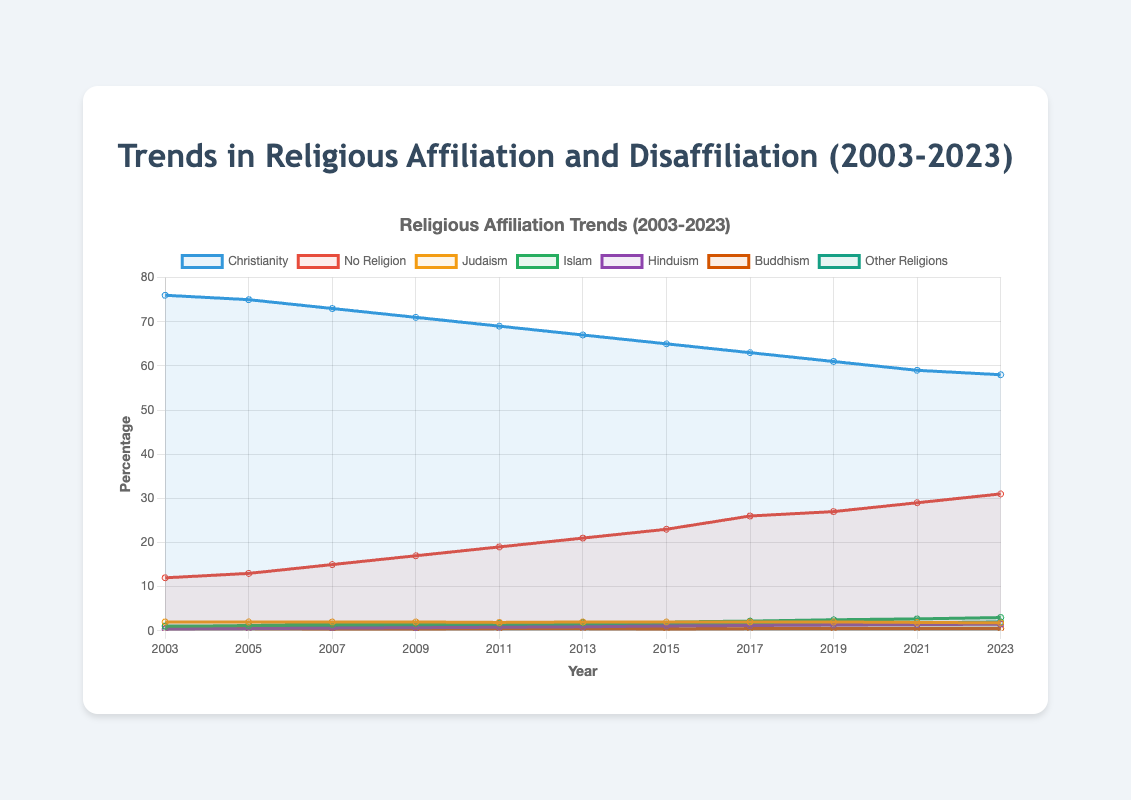What is the general trend of Christianity from 2003 to 2023? The line representing Christianity shows a decreasing trend from 76% in 2003 to 58% in 2023. Observing the overall direction of the line, it is evident that the percentage has consistently dropped over the 20-year period.
Answer: Decreasing Which religious affiliation had the highest increase in percentage over the 20 years, and by how much did it increase? To find the highest increase, we compare the percentages for each religion from 2003 to 2023. The "No Religion" category increased from 12% to 31%, a change of 19 percentage points. No other category saw a greater increase.
Answer: No Religion, 19 percentage points Between 2015 and 2023, which religion saw the highest growth rate? Calculate the growth rates for each religion between 2015 and 2023 by dividing the percentage increase by the number of years. "Islam" increased from 2% to 3%, a 1% increase over 8 years, equating to a growth rate of 0.125 percent per year, the highest among the groups.
Answer: Islam How does the percentage of people identifying as "No Religion" in 2023 compare to those identifying as "Christianity"? In 2023, "No Religion" has 31% and "Christianity" has 58%. We see that Christianity's percentage is higher than "No Religion" by comparing their values directly.
Answer: Christianity is higher by 27% Which group remained relatively stable over the period from 2003 to 2023, and what was the change in percentage? Looking at the lines, "Buddhism" shows minimal fluctuation, remaining around 0.5% throughout the years with only minor variations. The change in percentage is negligible.
Answer: Buddhism, around 0% In which year did "No Religion" overtake "Christianity" as the second-highest percentage, if at all? By examining the crossing points of the lines, we observe that "No Religion" never overtakes "Christianity" but steadily increases over the years while Christianity decreases. "Christianity" consistently maintains a higher percentage.
Answer: Never overtakes Among the minority religions listed (Judaism, Islam, Hinduism, Buddhism, Other Religions), which one showed the most steady increase from 2003 to 2023 and how can you tell? "Islam" shows a steady increase with no significant dips or rises, progressing consistently from 1% in 2003 to 3% in 2023. The smooth upward line indicates this steady increase.
Answer: Islam What is the combined percentage of Islam and Hinduism in 2023, and what does it suggest about their growth? The percentage for Islam is 3%, and for Hinduism, it is 1.5% in 2023. Summing them gives 3% + 1.5% = 4.5%. This combined value suggests both religions have been slowly but steadily growing over the years.
Answer: 4.5% Compare the percentages of people identifying with "Other Religions" in 2003 and 2023. What is the percentage increase? "Other Religions" increased from 1.1% in 2003 to 2% in 2023. The percentage increase is calculated as (2 - 1.1) / 1.1 * 100% = 81.82%.
Answer: 81.82% How do the trends in religious affiliation reflect broader societal changes, if any? Observing that "No Religion" has increased significantly while "Christianity" has been decreasing, this trend may suggest a shift towards secularism or a society that places less emphasis on traditional religious practice. The growth of minority religions such as Islam and Hinduism could reflect increased diversity and immigration.
Answer: Indicates secularism and diversity 